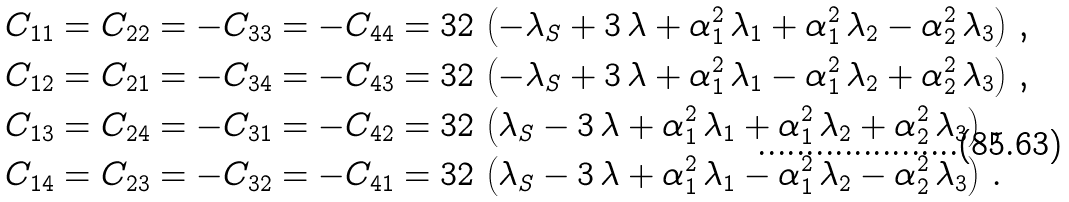<formula> <loc_0><loc_0><loc_500><loc_500>& C _ { 1 1 } = C _ { 2 2 } = - C _ { 3 3 } = - C _ { 4 4 } = 3 2 \, \left ( - \lambda _ { S } + 3 \, \lambda + \alpha _ { 1 } ^ { 2 } \, \lambda _ { 1 } + \alpha _ { 1 } ^ { 2 } \, \lambda _ { 2 } - \alpha _ { 2 } ^ { 2 } \, \lambda _ { 3 } \right ) \, , \\ & C _ { 1 2 } = C _ { 2 1 } = - C _ { 3 4 } = - C _ { 4 3 } = 3 2 \, \left ( - \lambda _ { S } + 3 \, \lambda + \alpha _ { 1 } ^ { 2 } \, \lambda _ { 1 } - \alpha _ { 1 } ^ { 2 } \, \lambda _ { 2 } + \alpha _ { 2 } ^ { 2 } \, \lambda _ { 3 } \right ) \, , \\ & C _ { 1 3 } = C _ { 2 4 } = - C _ { 3 1 } = - C _ { 4 2 } = 3 2 \, \left ( \lambda _ { S } - 3 \, \lambda + \alpha _ { 1 } ^ { 2 } \, \lambda _ { 1 } + \alpha _ { 1 } ^ { 2 } \, \lambda _ { 2 } + \alpha _ { 2 } ^ { 2 } \, \lambda _ { 3 } \right ) \, , \\ & C _ { 1 4 } = C _ { 2 3 } = - C _ { 3 2 } = - C _ { 4 1 } = 3 2 \, \left ( \lambda _ { S } - 3 \, \lambda + \alpha _ { 1 } ^ { 2 } \, \lambda _ { 1 } - \alpha _ { 1 } ^ { 2 } \, \lambda _ { 2 } - \alpha _ { 2 } ^ { 2 } \, \lambda _ { 3 } \right ) \, . \\</formula> 